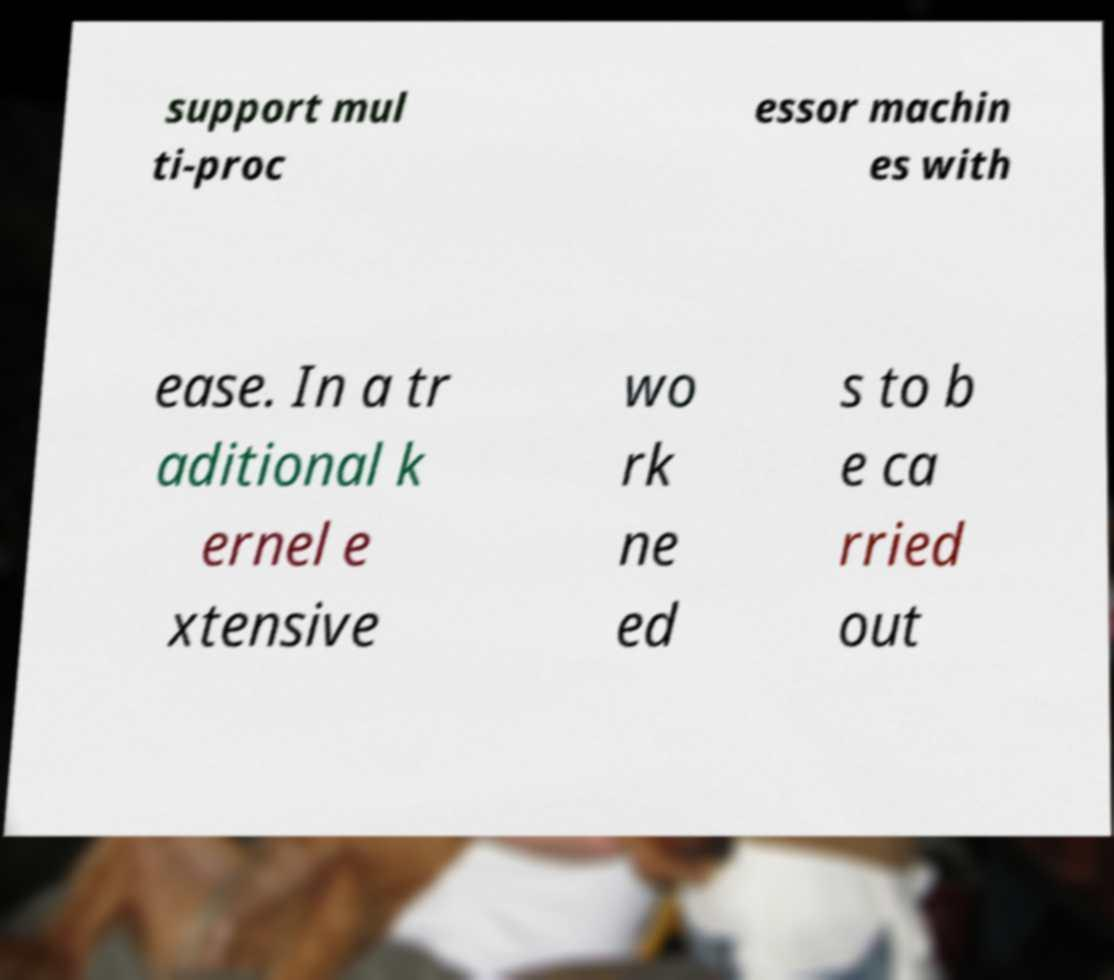Can you read and provide the text displayed in the image?This photo seems to have some interesting text. Can you extract and type it out for me? support mul ti-proc essor machin es with ease. In a tr aditional k ernel e xtensive wo rk ne ed s to b e ca rried out 